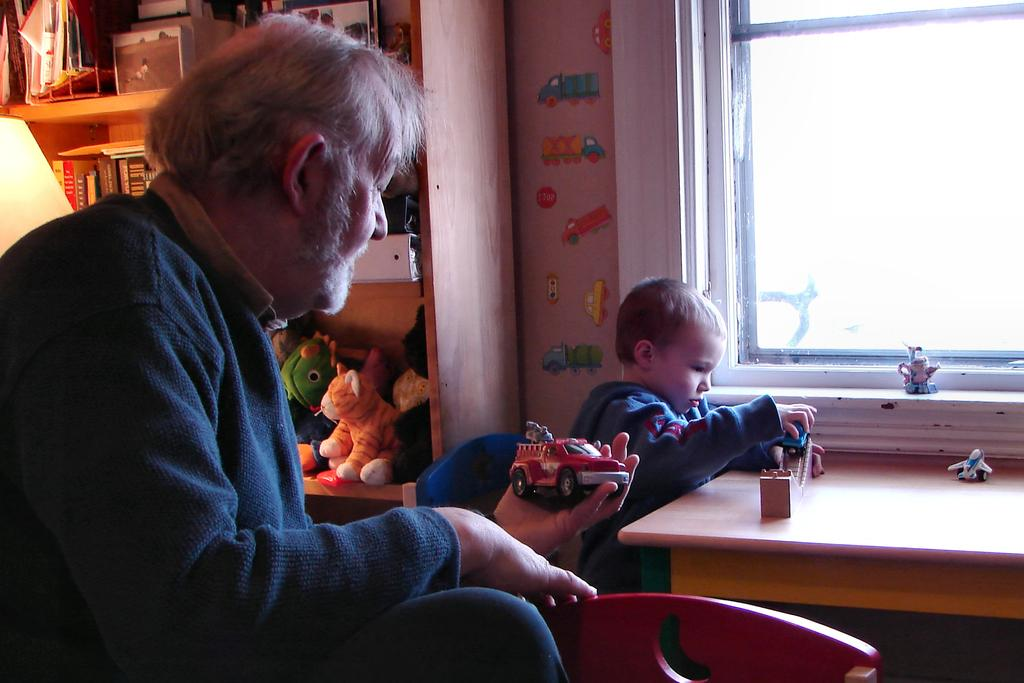What is the man in the image doing? The man is sitting in the image. What is the man holding in his hands? The man is holding a toy in his hands. What can be seen in the background of the image? There is a window in the image. What type of property does the man own, as seen in the image? There is no information about property ownership in the image. What month is it in the image? The image does not provide any information about the month. 